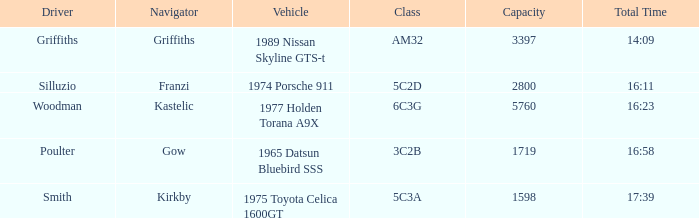What type of car has a 6c3g classification? 1977 Holden Torana A9X. 